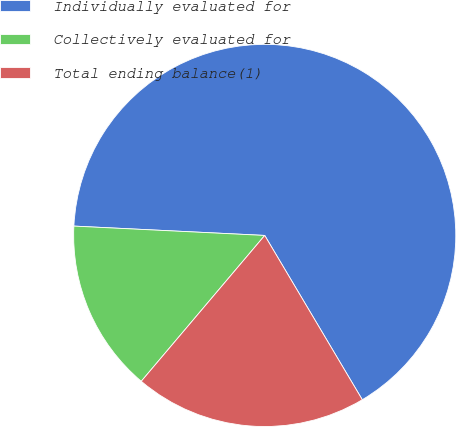<chart> <loc_0><loc_0><loc_500><loc_500><pie_chart><fcel>Individually evaluated for<fcel>Collectively evaluated for<fcel>Total ending balance(1)<nl><fcel>65.69%<fcel>14.6%<fcel>19.71%<nl></chart> 